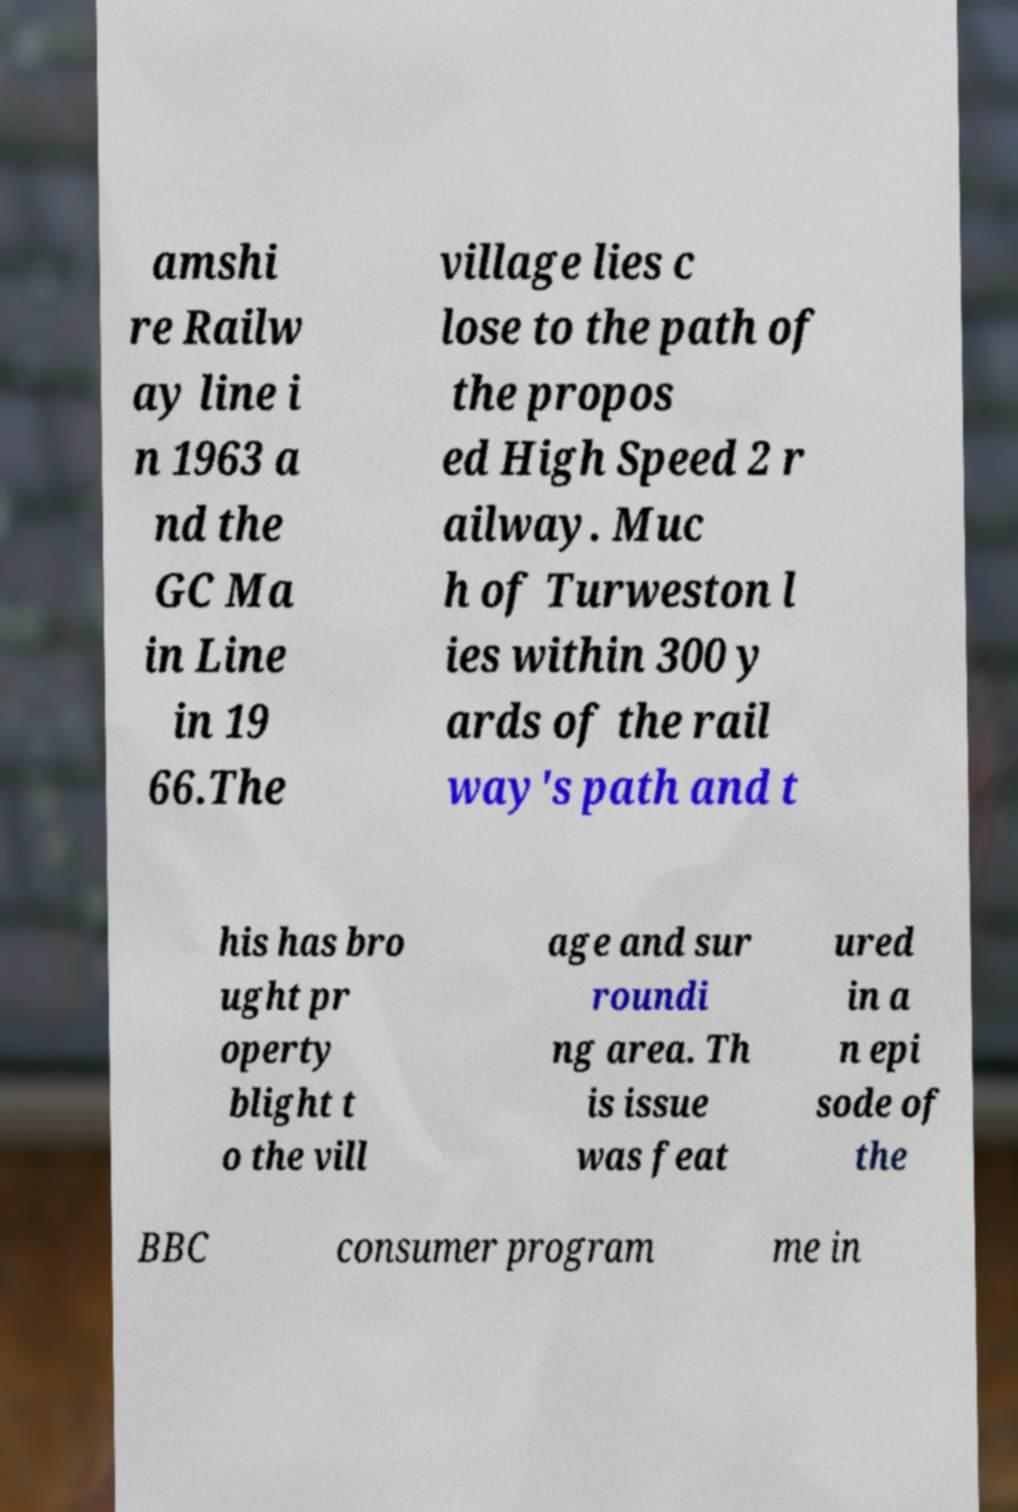Could you extract and type out the text from this image? amshi re Railw ay line i n 1963 a nd the GC Ma in Line in 19 66.The village lies c lose to the path of the propos ed High Speed 2 r ailway. Muc h of Turweston l ies within 300 y ards of the rail way's path and t his has bro ught pr operty blight t o the vill age and sur roundi ng area. Th is issue was feat ured in a n epi sode of the BBC consumer program me in 